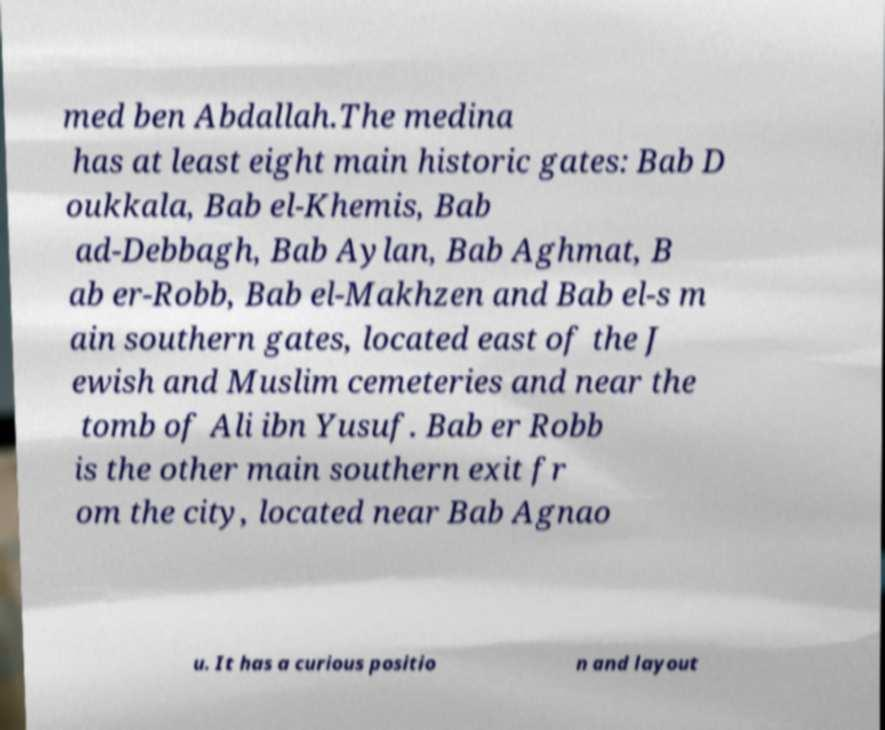Could you assist in decoding the text presented in this image and type it out clearly? med ben Abdallah.The medina has at least eight main historic gates: Bab D oukkala, Bab el-Khemis, Bab ad-Debbagh, Bab Aylan, Bab Aghmat, B ab er-Robb, Bab el-Makhzen and Bab el-s m ain southern gates, located east of the J ewish and Muslim cemeteries and near the tomb of Ali ibn Yusuf. Bab er Robb is the other main southern exit fr om the city, located near Bab Agnao u. It has a curious positio n and layout 